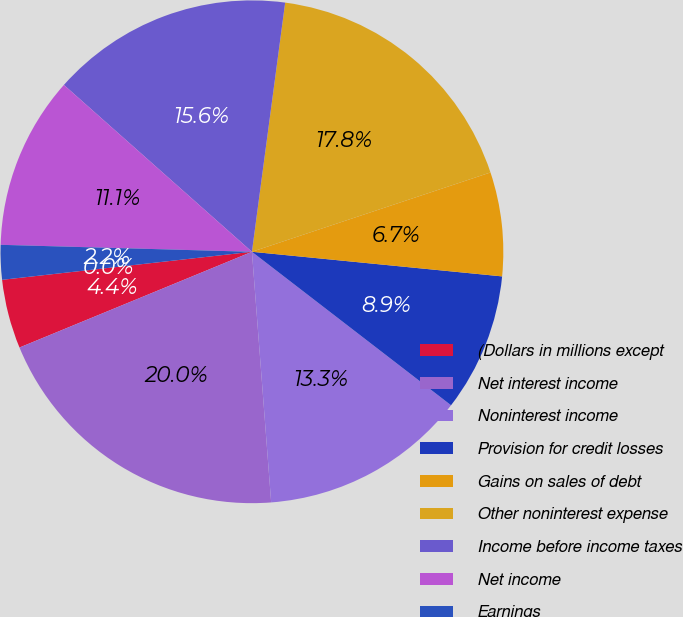Convert chart. <chart><loc_0><loc_0><loc_500><loc_500><pie_chart><fcel>(Dollars in millions except<fcel>Net interest income<fcel>Noninterest income<fcel>Provision for credit losses<fcel>Gains on sales of debt<fcel>Other noninterest expense<fcel>Income before income taxes<fcel>Net income<fcel>Earnings<fcel>Diluted earnings<nl><fcel>4.44%<fcel>20.0%<fcel>13.33%<fcel>8.89%<fcel>6.67%<fcel>17.78%<fcel>15.56%<fcel>11.11%<fcel>2.22%<fcel>0.0%<nl></chart> 